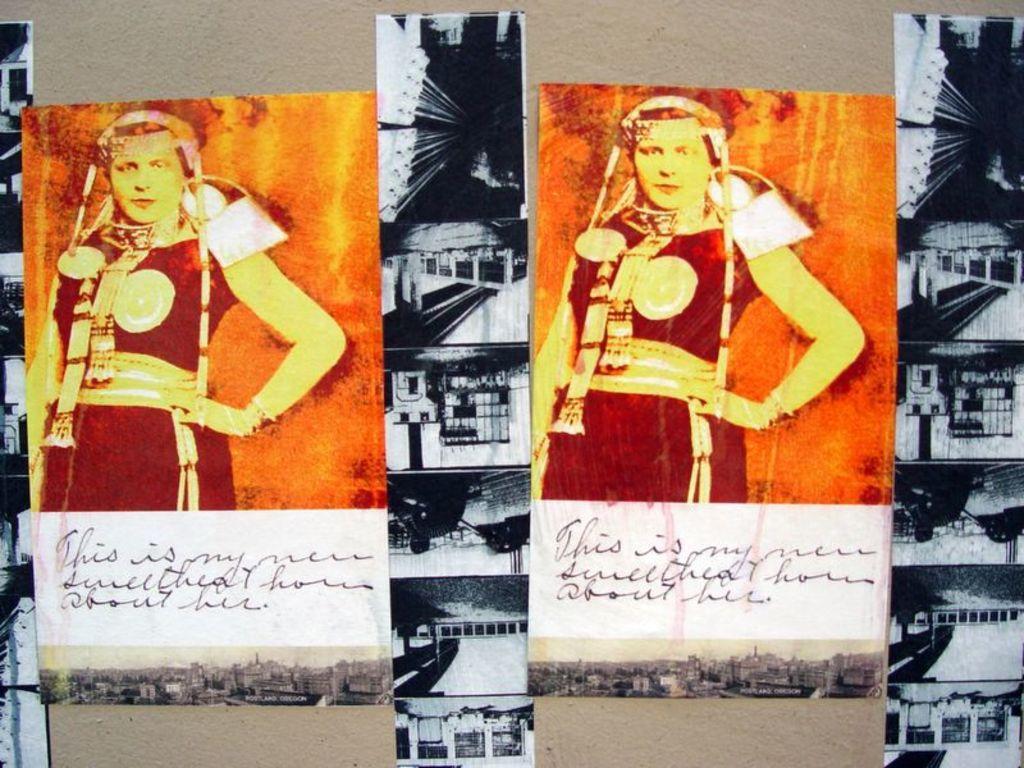Describe this image in one or two sentences. In this image I can see many photos to the board. And I can see the colorful photo of the women. And the woman is wearing the dress. In other photos I can see the house and these are black and white photos. 